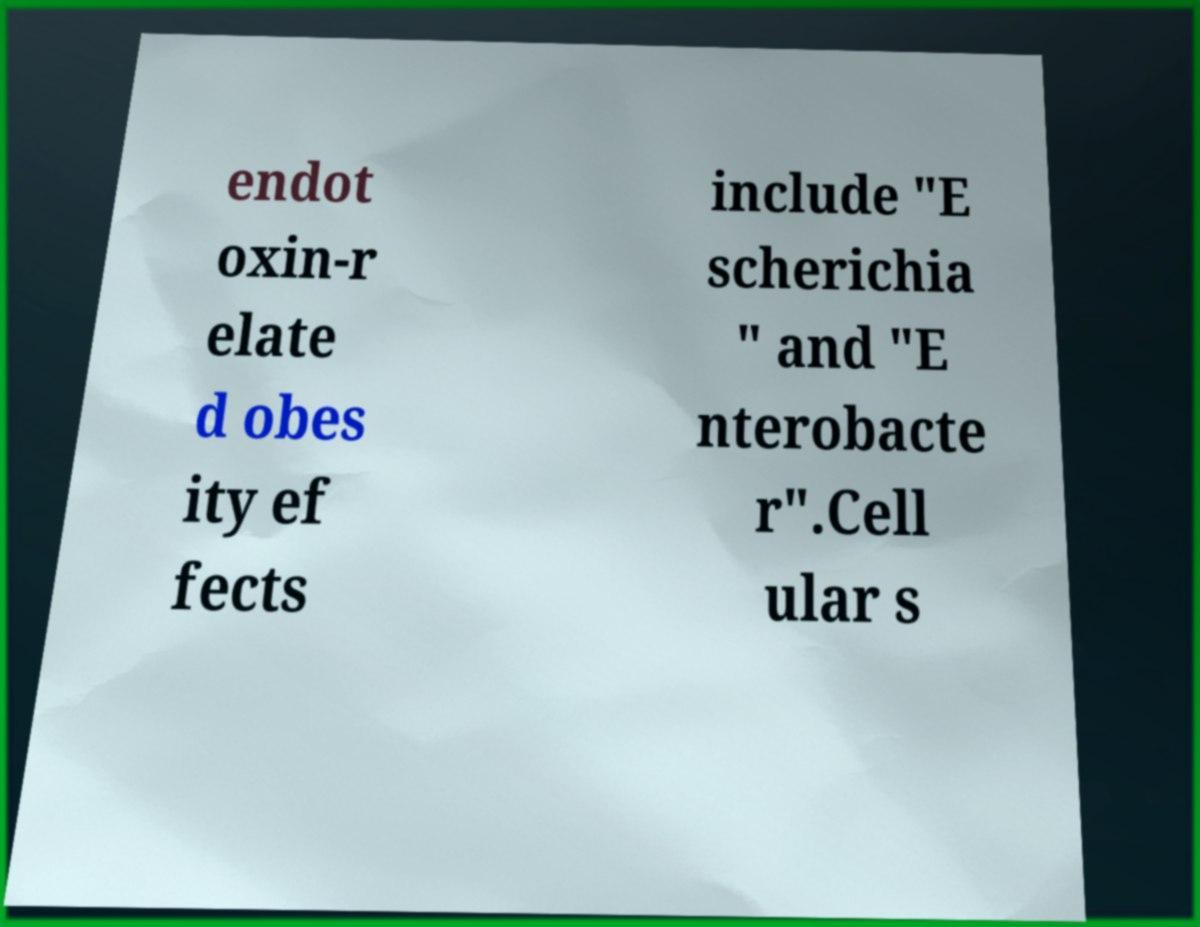Can you accurately transcribe the text from the provided image for me? endot oxin-r elate d obes ity ef fects include "E scherichia " and "E nterobacte r".Cell ular s 